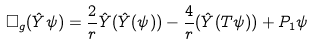<formula> <loc_0><loc_0><loc_500><loc_500>\Box _ { g } ( \hat { Y } \psi ) = \frac { 2 } r \hat { Y } ( \hat { Y } ( \psi ) ) - \frac { 4 } { r } ( \hat { Y } ( T \psi ) ) + P _ { 1 } \psi</formula> 